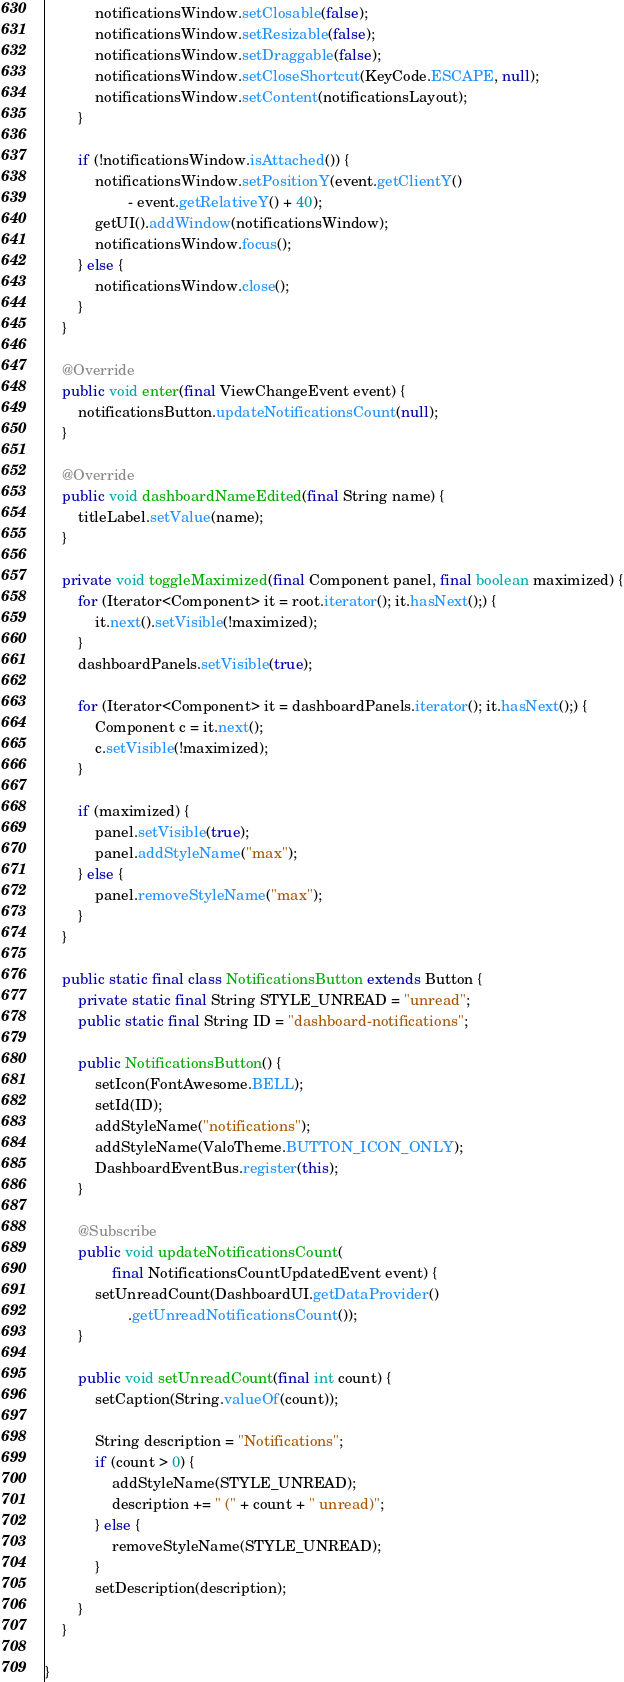Convert code to text. <code><loc_0><loc_0><loc_500><loc_500><_Java_>            notificationsWindow.setClosable(false);
            notificationsWindow.setResizable(false);
            notificationsWindow.setDraggable(false);
            notificationsWindow.setCloseShortcut(KeyCode.ESCAPE, null);
            notificationsWindow.setContent(notificationsLayout);
        }

        if (!notificationsWindow.isAttached()) {
            notificationsWindow.setPositionY(event.getClientY()
                    - event.getRelativeY() + 40);
            getUI().addWindow(notificationsWindow);
            notificationsWindow.focus();
        } else {
            notificationsWindow.close();
        }
    }

    @Override
    public void enter(final ViewChangeEvent event) {
        notificationsButton.updateNotificationsCount(null);
    }

    @Override
    public void dashboardNameEdited(final String name) {
        titleLabel.setValue(name);
    }

    private void toggleMaximized(final Component panel, final boolean maximized) {
        for (Iterator<Component> it = root.iterator(); it.hasNext();) {
            it.next().setVisible(!maximized);
        }
        dashboardPanels.setVisible(true);

        for (Iterator<Component> it = dashboardPanels.iterator(); it.hasNext();) {
            Component c = it.next();
            c.setVisible(!maximized);
        }

        if (maximized) {
            panel.setVisible(true);
            panel.addStyleName("max");
        } else {
            panel.removeStyleName("max");
        }
    }

    public static final class NotificationsButton extends Button {
        private static final String STYLE_UNREAD = "unread";
        public static final String ID = "dashboard-notifications";

        public NotificationsButton() {
            setIcon(FontAwesome.BELL);
            setId(ID);
            addStyleName("notifications");
            addStyleName(ValoTheme.BUTTON_ICON_ONLY);
            DashboardEventBus.register(this);
        }

        @Subscribe
        public void updateNotificationsCount(
                final NotificationsCountUpdatedEvent event) {
            setUnreadCount(DashboardUI.getDataProvider()
                    .getUnreadNotificationsCount());
        }

        public void setUnreadCount(final int count) {
            setCaption(String.valueOf(count));

            String description = "Notifications";
            if (count > 0) {
                addStyleName(STYLE_UNREAD);
                description += " (" + count + " unread)";
            } else {
                removeStyleName(STYLE_UNREAD);
            }
            setDescription(description);
        }
    }

}
</code> 